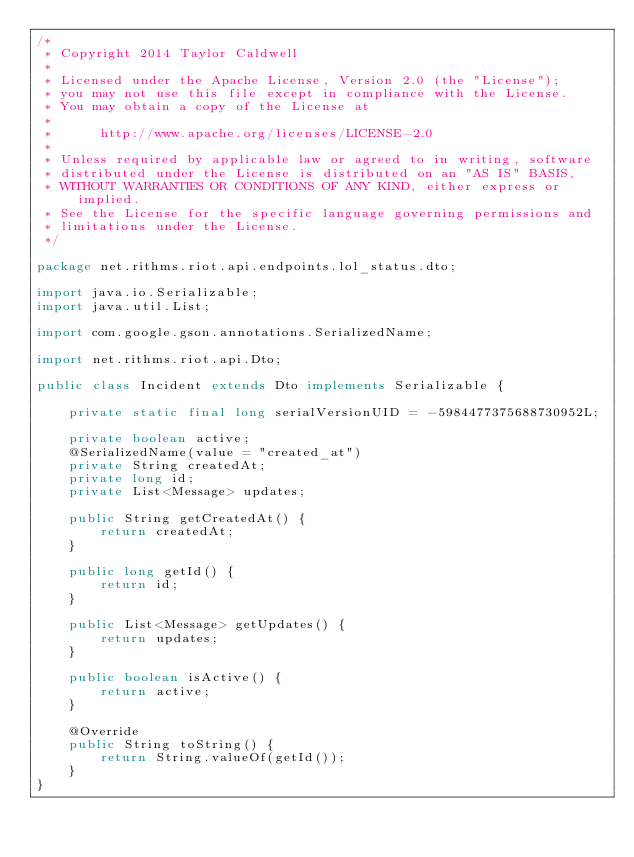<code> <loc_0><loc_0><loc_500><loc_500><_Java_>/*
 * Copyright 2014 Taylor Caldwell
 *
 * Licensed under the Apache License, Version 2.0 (the "License");
 * you may not use this file except in compliance with the License.
 * You may obtain a copy of the License at
 *
 *      http://www.apache.org/licenses/LICENSE-2.0
 *
 * Unless required by applicable law or agreed to in writing, software
 * distributed under the License is distributed on an "AS IS" BASIS,
 * WITHOUT WARRANTIES OR CONDITIONS OF ANY KIND, either express or implied.
 * See the License for the specific language governing permissions and
 * limitations under the License.
 */

package net.rithms.riot.api.endpoints.lol_status.dto;

import java.io.Serializable;
import java.util.List;

import com.google.gson.annotations.SerializedName;

import net.rithms.riot.api.Dto;

public class Incident extends Dto implements Serializable {

	private static final long serialVersionUID = -5984477375688730952L;

	private boolean active;
	@SerializedName(value = "created_at")
	private String createdAt;
	private long id;
	private List<Message> updates;

	public String getCreatedAt() {
		return createdAt;
	}

	public long getId() {
		return id;
	}

	public List<Message> getUpdates() {
		return updates;
	}

	public boolean isActive() {
		return active;
	}

	@Override
	public String toString() {
		return String.valueOf(getId());
	}
}</code> 